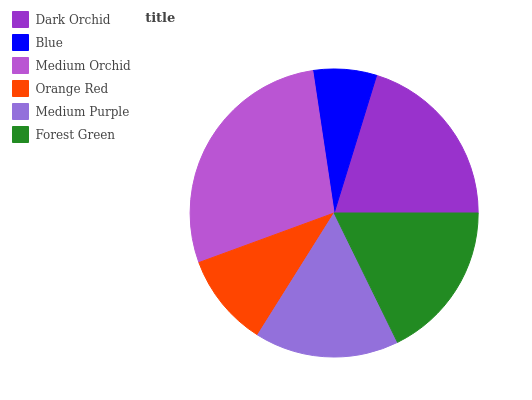Is Blue the minimum?
Answer yes or no. Yes. Is Medium Orchid the maximum?
Answer yes or no. Yes. Is Medium Orchid the minimum?
Answer yes or no. No. Is Blue the maximum?
Answer yes or no. No. Is Medium Orchid greater than Blue?
Answer yes or no. Yes. Is Blue less than Medium Orchid?
Answer yes or no. Yes. Is Blue greater than Medium Orchid?
Answer yes or no. No. Is Medium Orchid less than Blue?
Answer yes or no. No. Is Forest Green the high median?
Answer yes or no. Yes. Is Medium Purple the low median?
Answer yes or no. Yes. Is Medium Orchid the high median?
Answer yes or no. No. Is Dark Orchid the low median?
Answer yes or no. No. 